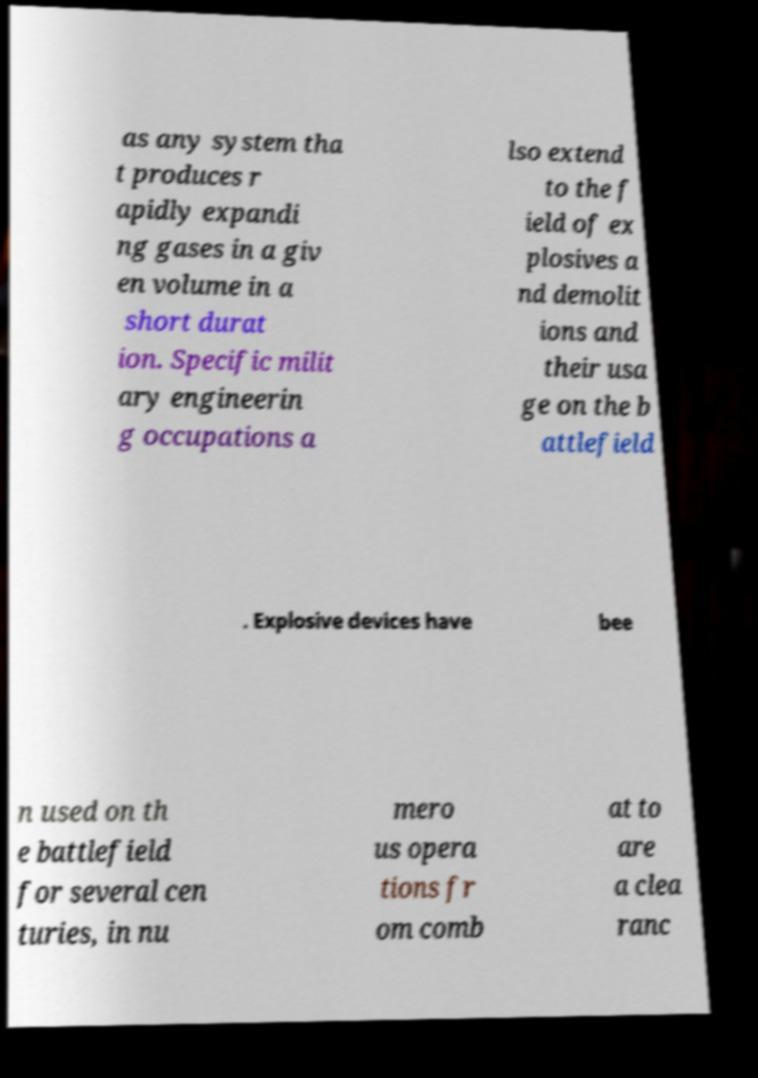There's text embedded in this image that I need extracted. Can you transcribe it verbatim? as any system tha t produces r apidly expandi ng gases in a giv en volume in a short durat ion. Specific milit ary engineerin g occupations a lso extend to the f ield of ex plosives a nd demolit ions and their usa ge on the b attlefield . Explosive devices have bee n used on th e battlefield for several cen turies, in nu mero us opera tions fr om comb at to are a clea ranc 